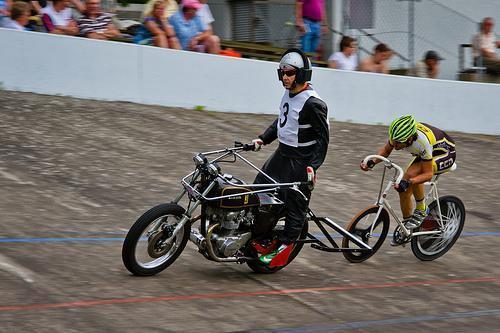How many people are riding bikes?
Give a very brief answer. 2. How many helmets?
Give a very brief answer. 2. How many riders are shown?
Give a very brief answer. 2. How many men are on the track?
Give a very brief answer. 2. 